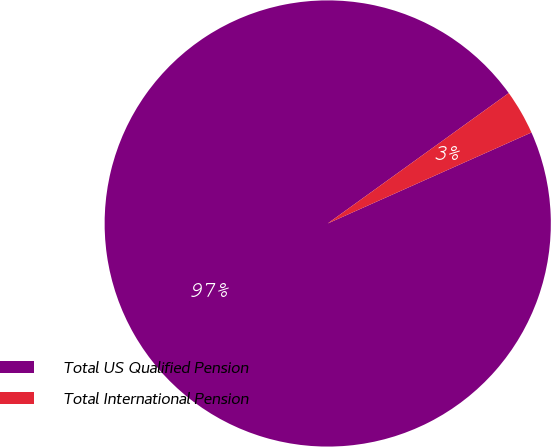<chart> <loc_0><loc_0><loc_500><loc_500><pie_chart><fcel>Total US Qualified Pension<fcel>Total International Pension<nl><fcel>96.75%<fcel>3.25%<nl></chart> 